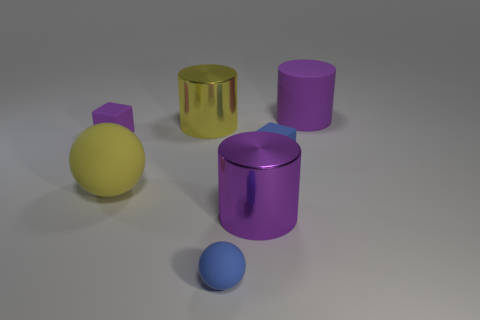Subtract all spheres. How many objects are left? 5 Add 7 yellow matte cylinders. How many yellow matte cylinders exist? 7 Subtract 0 brown cylinders. How many objects are left? 7 Subtract all purple cubes. Subtract all tiny red metal cylinders. How many objects are left? 6 Add 7 large cylinders. How many large cylinders are left? 10 